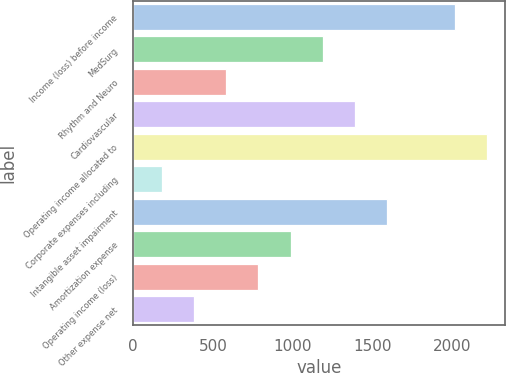<chart> <loc_0><loc_0><loc_500><loc_500><bar_chart><fcel>Income (loss) before income<fcel>MedSurg<fcel>Rhythm and Neuro<fcel>Cardiovascular<fcel>Operating income allocated to<fcel>Corporate expenses including<fcel>Intangible asset impairment<fcel>Amortization expense<fcel>Operating income (loss)<fcel>Other expense net<nl><fcel>2016<fcel>1189.5<fcel>583.2<fcel>1391.6<fcel>2218.1<fcel>179<fcel>1593.7<fcel>987.4<fcel>785.3<fcel>381.1<nl></chart> 